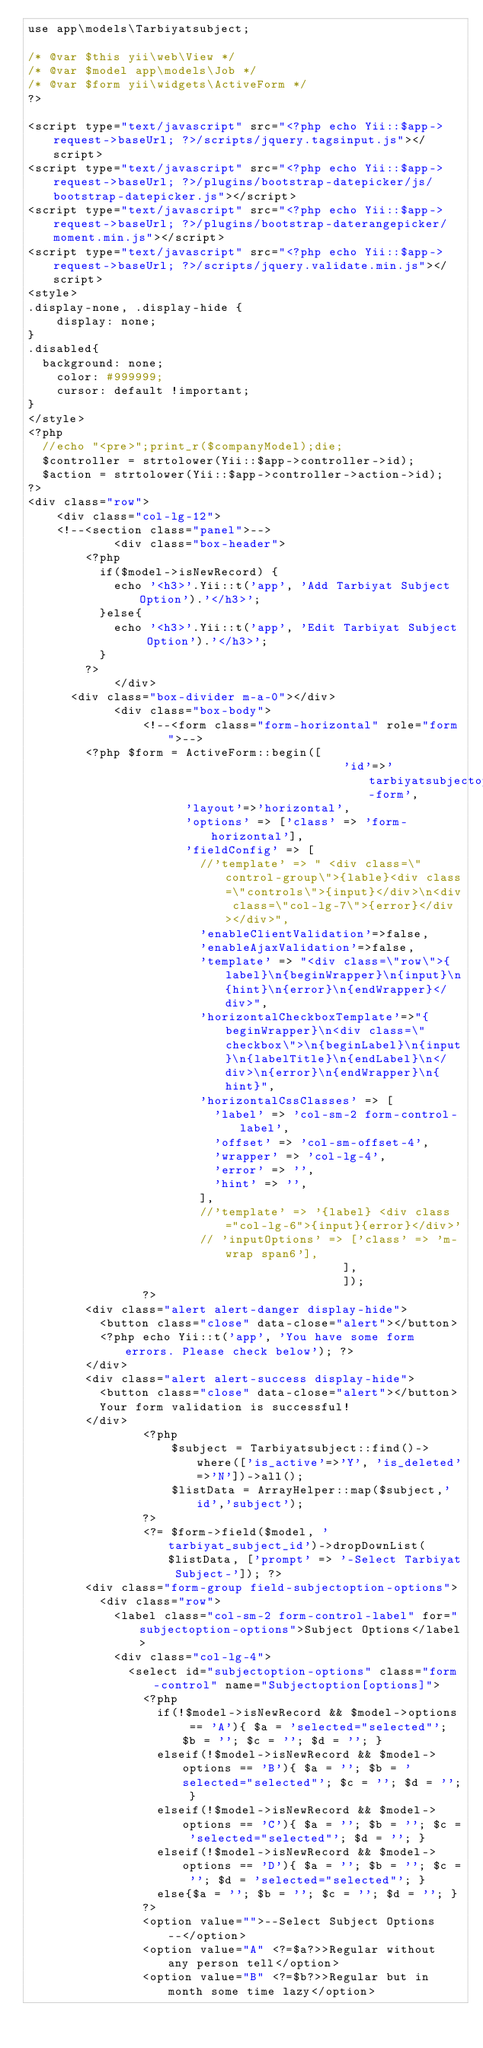<code> <loc_0><loc_0><loc_500><loc_500><_PHP_>use app\models\Tarbiyatsubject;

/* @var $this yii\web\View */
/* @var $model app\models\Job */
/* @var $form yii\widgets\ActiveForm */
?>

<script type="text/javascript" src="<?php echo Yii::$app->request->baseUrl; ?>/scripts/jquery.tagsinput.js"></script>
<script type="text/javascript" src="<?php echo Yii::$app->request->baseUrl; ?>/plugins/bootstrap-datepicker/js/bootstrap-datepicker.js"></script>
<script type="text/javascript" src="<?php echo Yii::$app->request->baseUrl; ?>/plugins/bootstrap-daterangepicker/moment.min.js"></script>
<script type="text/javascript" src="<?php echo Yii::$app->request->baseUrl; ?>/scripts/jquery.validate.min.js"></script>
<style>
.display-none, .display-hide {
    display: none;
}
.disabled{
	background: none;
    color: #999999;
    cursor: default !important;
}
</style>
<?php
	//echo "<pre>";print_r($companyModel);die;
	$controller = strtolower(Yii::$app->controller->id);
	$action = strtolower(Yii::$app->controller->action->id);
?>
<div class="row">
    <div class="col-lg-12">
		<!--<section class="panel">-->
            <div class="box-header">
				<?php
					if($model->isNewRecord) {
						echo '<h3>'.Yii::t('app', 'Add Tarbiyat Subject Option').'</h3>';
					}else{
						echo '<h3>'.Yii::t('app', 'Edit Tarbiyat Subject Option').'</h3>';
					}
				?>
            </div>
			<div class="box-divider m-a-0"></div>
            <div class="box-body">
                <!--<form class="form-horizontal" role="form">-->
				<?php $form = ActiveForm::begin([
                                            'id'=>'tarbiyatsubjectoption-form',
											'layout'=>'horizontal',
											'options' => ['class' => 'form-horizontal'],
											'fieldConfig' => [
												//'template' => " <div class=\"control-group\">{lable}<div class=\"controls\">{input}</div>\n<div class=\"col-lg-7\">{error}</div></div>",
												'enableClientValidation'=>false,
												'enableAjaxValidation'=>false,
												'template' => "<div class=\"row\">{label}\n{beginWrapper}\n{input}\n{hint}\n{error}\n{endWrapper}</div>",
												'horizontalCheckboxTemplate'=>"{beginWrapper}\n<div class=\"checkbox\">\n{beginLabel}\n{input}\n{labelTitle}\n{endLabel}\n</div>\n{error}\n{endWrapper}\n{hint}",
												'horizontalCssClasses' => [
													'label' => 'col-sm-2 form-control-label',
													'offset' => 'col-sm-offset-4',
													'wrapper' => 'col-lg-4',
													'error' => '',
													'hint' => '',
												],
												//'template' => '{label} <div class="col-lg-6">{input}{error}</div>'
												// 'inputOptions' => ['class' => 'm-wrap span6'],
                                            ],
                                            ]);
                ?>
				<div class="alert alert-danger display-hide">
					<button class="close" data-close="alert"></button>
					<?php echo Yii::t('app', 'You have some form errors. Please check below'); ?>
				</div>
				<div class="alert alert-success display-hide">
					<button class="close" data-close="alert"></button>
					Your form validation is successful!
				</div>
                <?php
                    $subject = Tarbiyatsubject::find()->where(['is_active'=>'Y', 'is_deleted'=>'N'])->all();
                    $listData = ArrayHelper::map($subject,'id','subject');
                ?>
                <?= $form->field($model, 'tarbiyat_subject_id')->dropDownList($listData, ['prompt' => '-Select Tarbiyat Subject-']); ?>
				<div class="form-group field-subjectoption-options">
					<div class="row">
						<label class="col-sm-2 form-control-label" for="subjectoption-options">Subject Options</label>
						<div class="col-lg-4">
							<select id="subjectoption-options" class="form-control" name="Subjectoption[options]">
								<?php
									if(!$model->isNewRecord && $model->options == 'A'){ $a = 'selected="selected"'; $b = ''; $c = ''; $d = ''; }
									elseif(!$model->isNewRecord && $model->options == 'B'){ $a = ''; $b = 'selected="selected"'; $c = ''; $d = ''; }
									elseif(!$model->isNewRecord && $model->options == 'C'){ $a = ''; $b = ''; $c = 'selected="selected"'; $d = ''; }
									elseif(!$model->isNewRecord && $model->options == 'D'){ $a = ''; $b = ''; $c = ''; $d = 'selected="selected"'; }
									else{$a = ''; $b = ''; $c = ''; $d = ''; }
								?>
								<option value="">--Select Subject Options--</option>
								<option value="A" <?=$a?>>Regular without any person tell</option>
								<option value="B" <?=$b?>>Regular but in month some time lazy</option></code> 